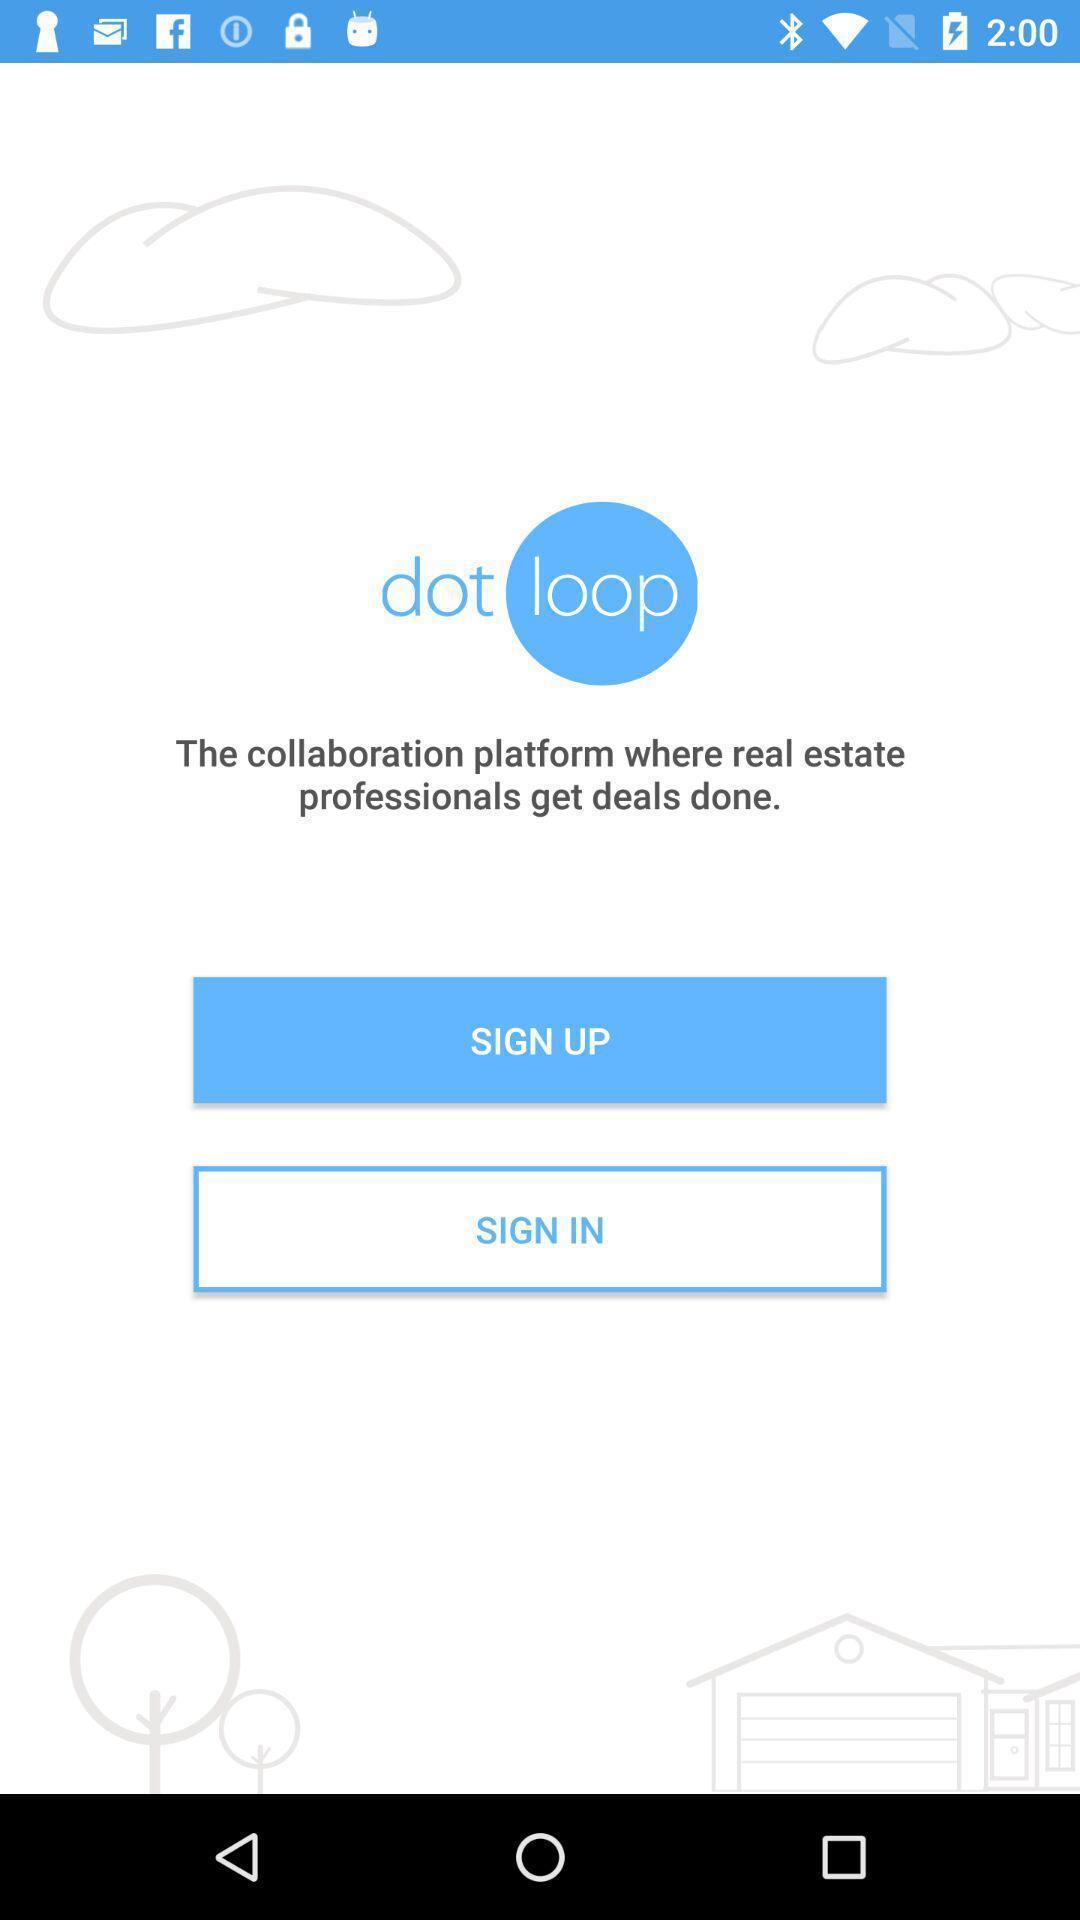Provide a detailed account of this screenshot. Welcome page for a real estate community collaboration app. 